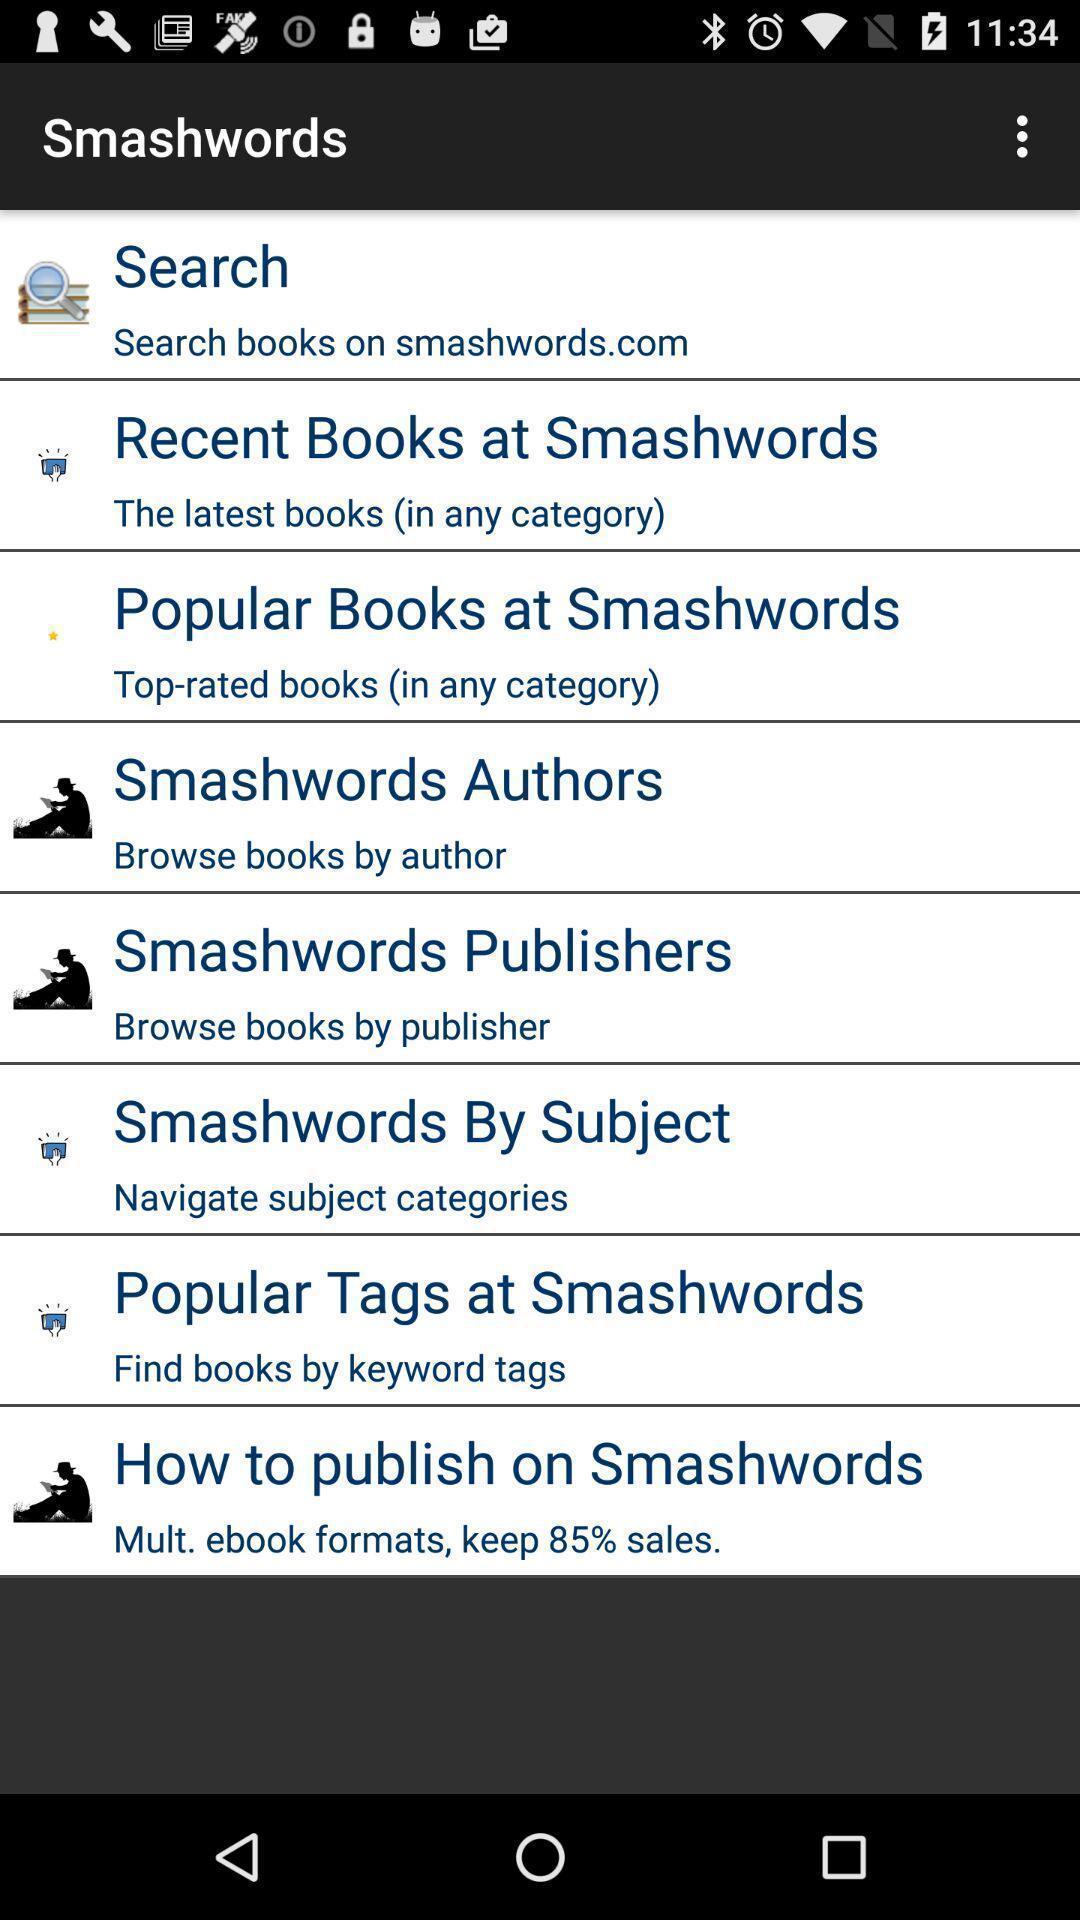What is the overall content of this screenshot? Page displays different categories of smash words. 